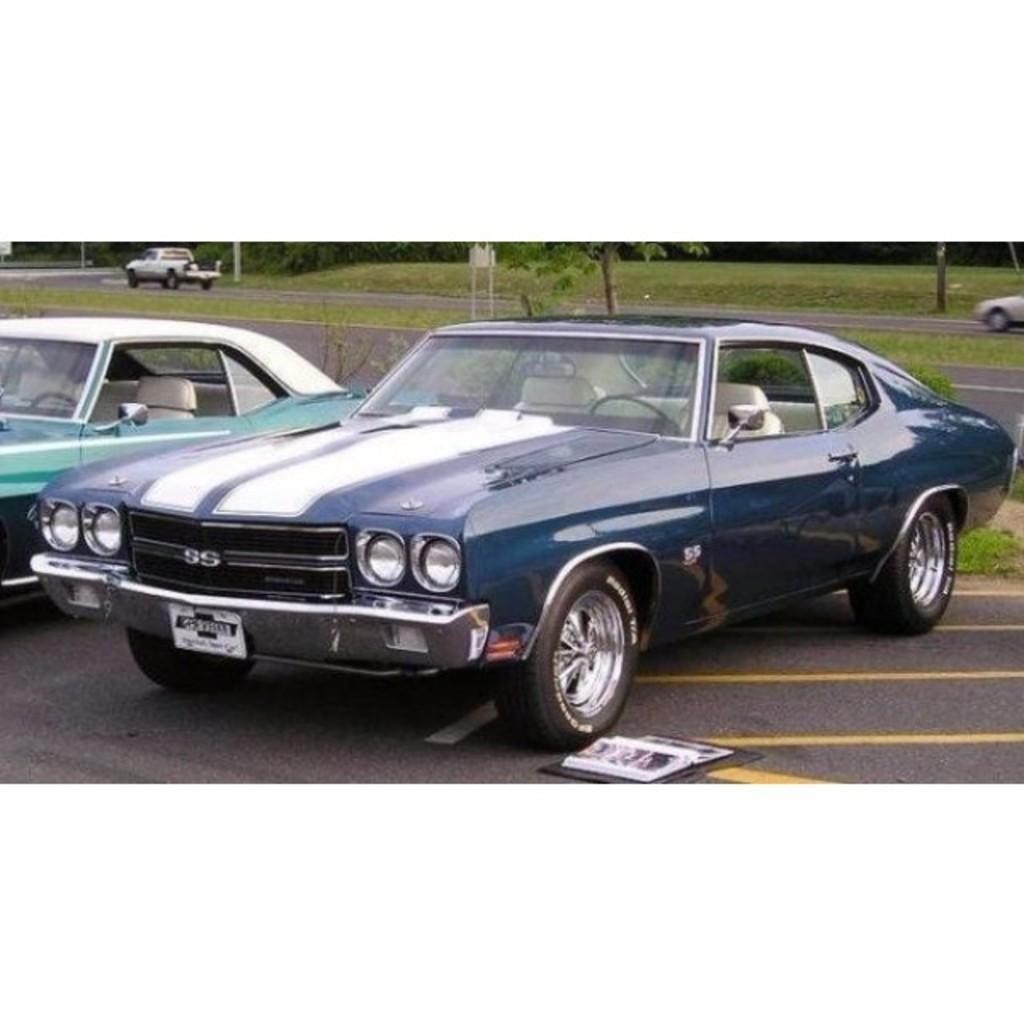Can you describe this image briefly? In this image there are two vehicles are parked, two are moving on the road. There are trees, sign board, grass and there is an object on the road. 